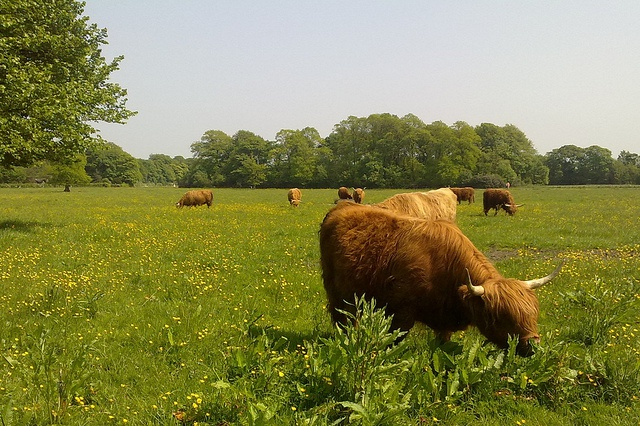Describe the objects in this image and their specific colors. I can see cow in olive, black, and maroon tones, cow in olive, orange, and tan tones, cow in olive, black, and maroon tones, cow in olive, maroon, and black tones, and cow in olive, maroon, and black tones in this image. 